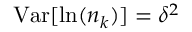<formula> <loc_0><loc_0><loc_500><loc_500>V a r [ \ln ( n _ { k } ) ] = \delta ^ { 2 }</formula> 